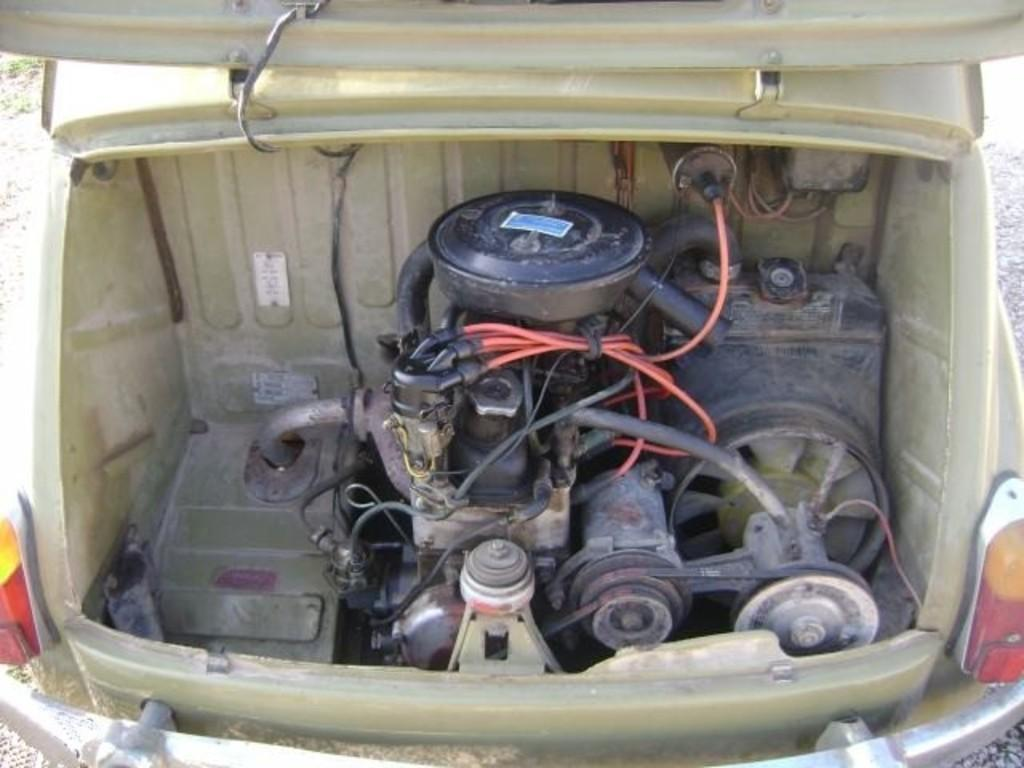What is the main subject of the image? The main subject of the image is a vehicle. Can you describe any specific features of the vehicle? Yes, the engine of the vehicle is visible in the front. What type of hearing aid is the driver using in the image? There is no driver present in the image, and therefore no hearing aid can be observed. 